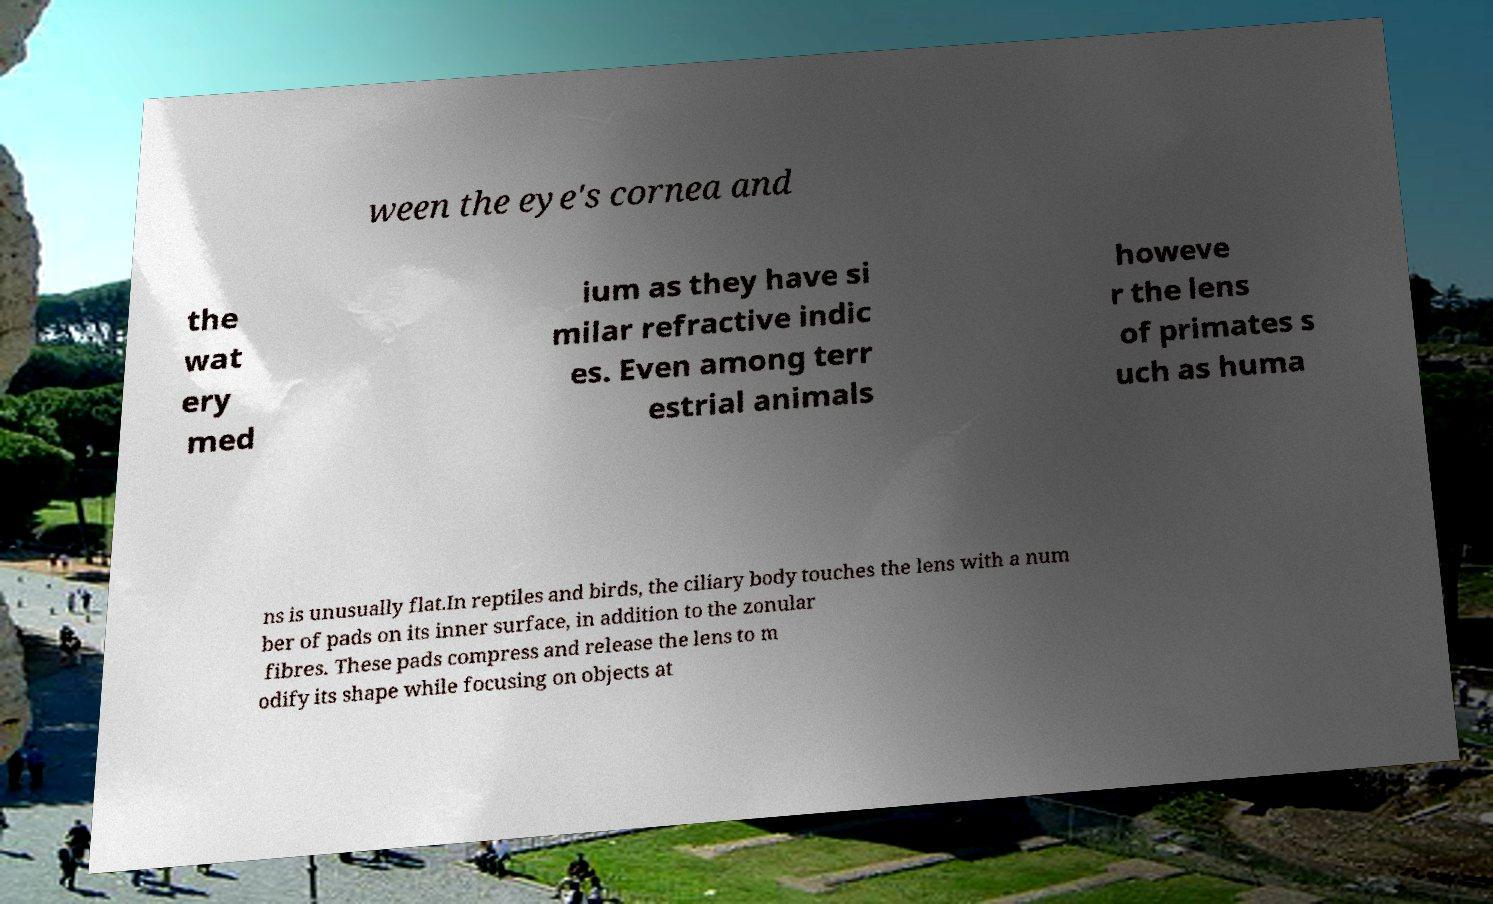Please identify and transcribe the text found in this image. ween the eye's cornea and the wat ery med ium as they have si milar refractive indic es. Even among terr estrial animals howeve r the lens of primates s uch as huma ns is unusually flat.In reptiles and birds, the ciliary body touches the lens with a num ber of pads on its inner surface, in addition to the zonular fibres. These pads compress and release the lens to m odify its shape while focusing on objects at 